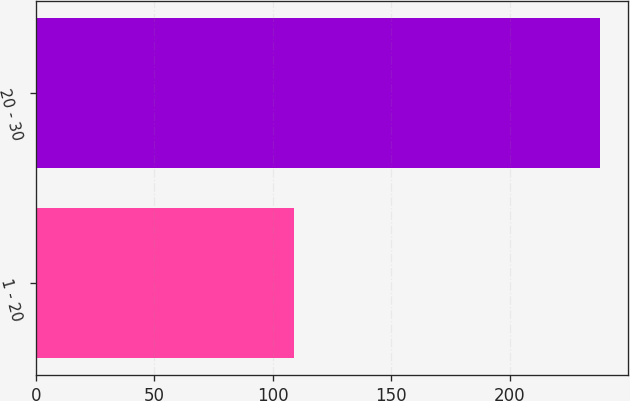Convert chart. <chart><loc_0><loc_0><loc_500><loc_500><bar_chart><fcel>1 - 20<fcel>20 - 30<nl><fcel>109<fcel>238<nl></chart> 